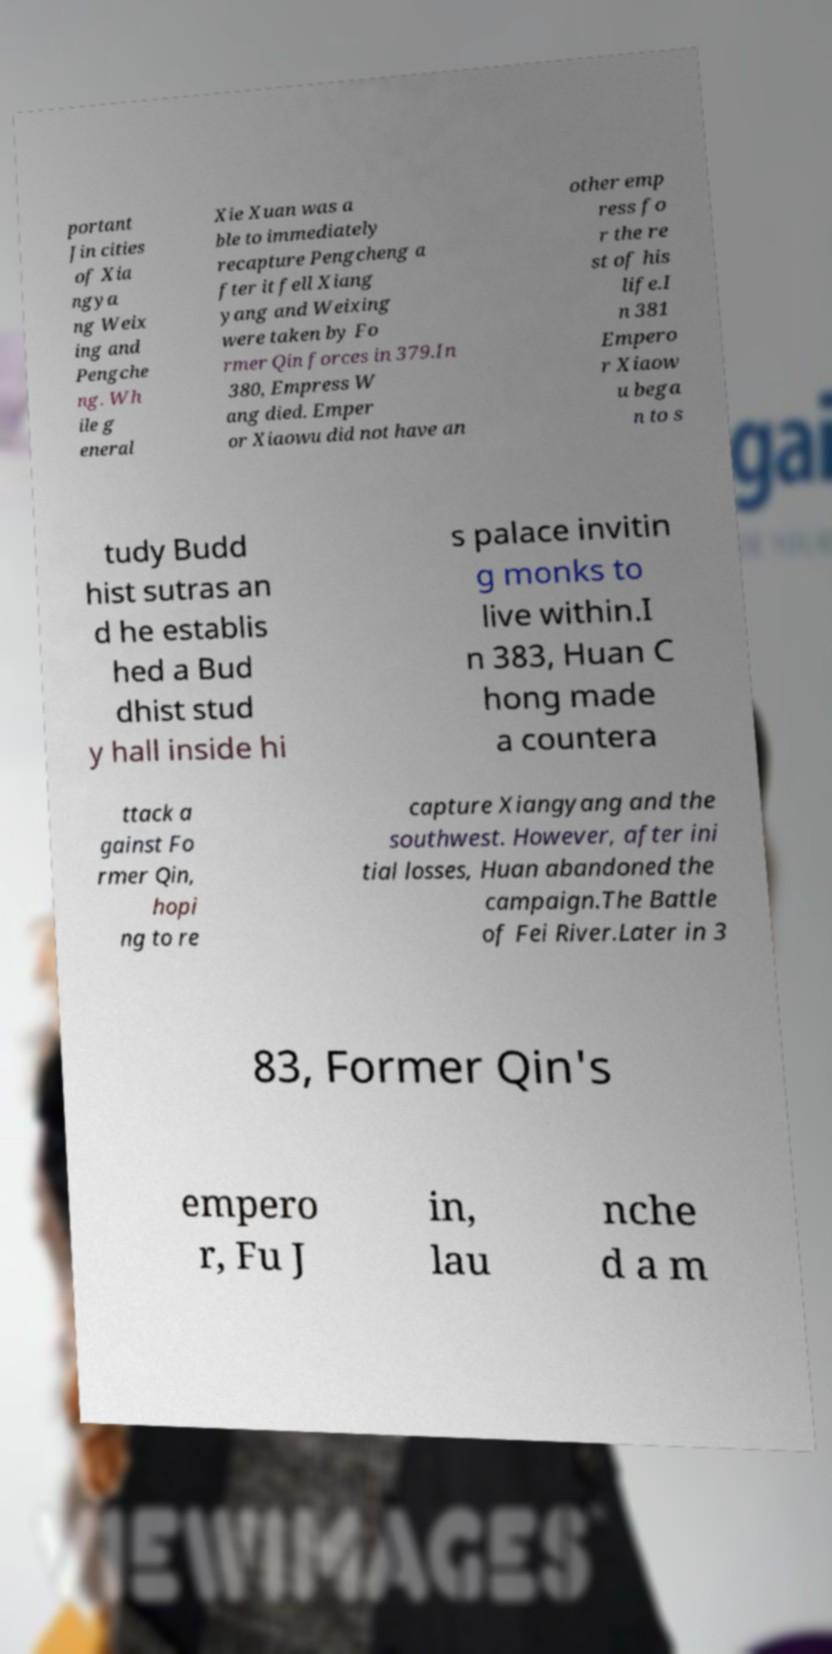Could you assist in decoding the text presented in this image and type it out clearly? portant Jin cities of Xia ngya ng Weix ing and Pengche ng. Wh ile g eneral Xie Xuan was a ble to immediately recapture Pengcheng a fter it fell Xiang yang and Weixing were taken by Fo rmer Qin forces in 379.In 380, Empress W ang died. Emper or Xiaowu did not have an other emp ress fo r the re st of his life.I n 381 Empero r Xiaow u bega n to s tudy Budd hist sutras an d he establis hed a Bud dhist stud y hall inside hi s palace invitin g monks to live within.I n 383, Huan C hong made a countera ttack a gainst Fo rmer Qin, hopi ng to re capture Xiangyang and the southwest. However, after ini tial losses, Huan abandoned the campaign.The Battle of Fei River.Later in 3 83, Former Qin's empero r, Fu J in, lau nche d a m 